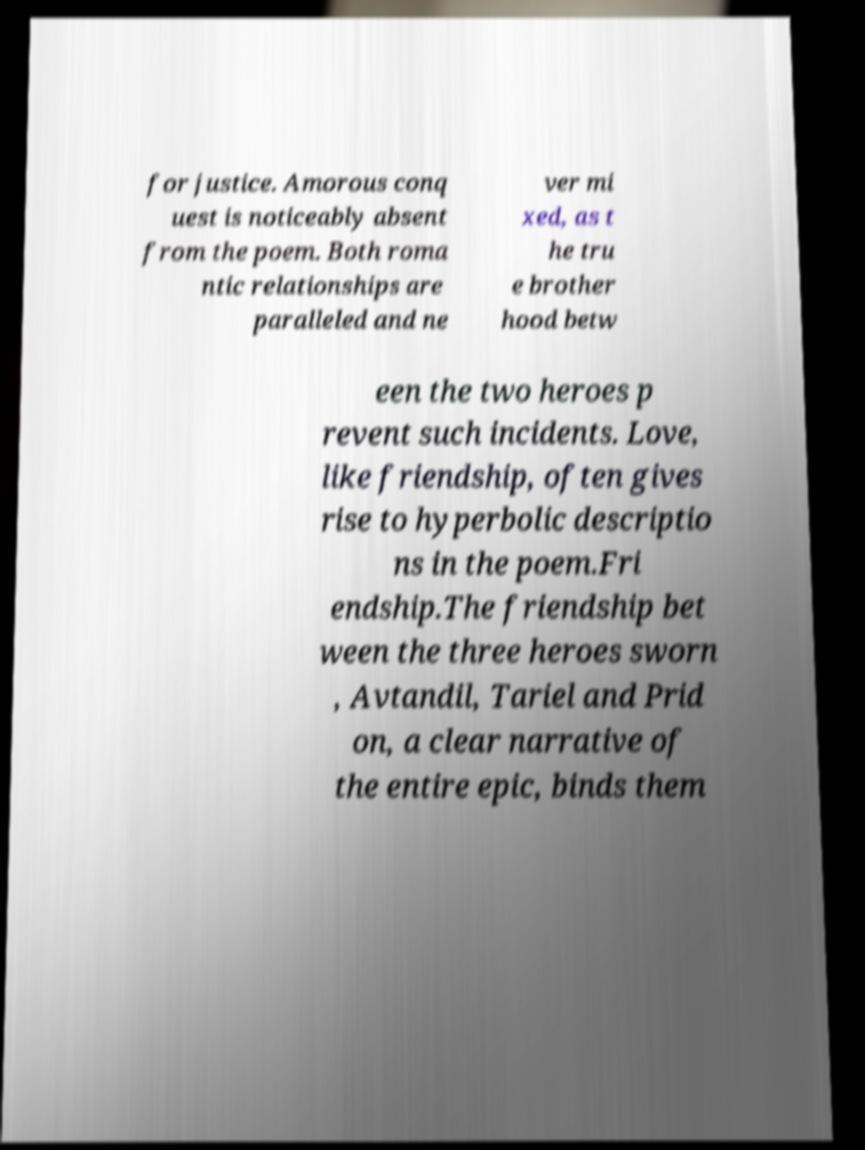I need the written content from this picture converted into text. Can you do that? for justice. Amorous conq uest is noticeably absent from the poem. Both roma ntic relationships are paralleled and ne ver mi xed, as t he tru e brother hood betw een the two heroes p revent such incidents. Love, like friendship, often gives rise to hyperbolic descriptio ns in the poem.Fri endship.The friendship bet ween the three heroes sworn , Avtandil, Tariel and Prid on, a clear narrative of the entire epic, binds them 